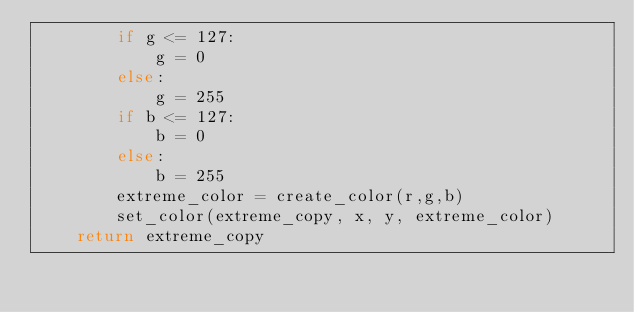Convert code to text. <code><loc_0><loc_0><loc_500><loc_500><_Python_>        if g <= 127:
            g = 0
        else:
            g = 255
        if b <= 127:
            b = 0
        else:
            b = 255
        extreme_color = create_color(r,g,b)
        set_color(extreme_copy, x, y, extreme_color) 
    return extreme_copy</code> 